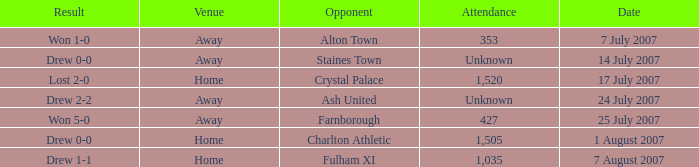Can you give me this table as a dict? {'header': ['Result', 'Venue', 'Opponent', 'Attendance', 'Date'], 'rows': [['Won 1-0', 'Away', 'Alton Town', '353', '7 July 2007'], ['Drew 0-0', 'Away', 'Staines Town', 'Unknown', '14 July 2007'], ['Lost 2-0', 'Home', 'Crystal Palace', '1,520', '17 July 2007'], ['Drew 2-2', 'Away', 'Ash United', 'Unknown', '24 July 2007'], ['Won 5-0', 'Away', 'Farnborough', '427', '25 July 2007'], ['Drew 0-0', 'Home', 'Charlton Athletic', '1,505', '1 August 2007'], ['Drew 1-1', 'Home', 'Fulham XI', '1,035', '7 August 2007']]} Tell me the date with result of won 1-0 7 July 2007. 